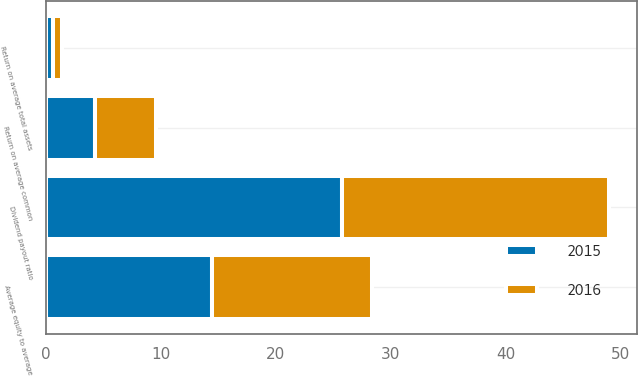Convert chart to OTSL. <chart><loc_0><loc_0><loc_500><loc_500><stacked_bar_chart><ecel><fcel>Return on average total assets<fcel>Return on average common<fcel>Dividend payout ratio<fcel>Average equity to average<nl><fcel>2016<fcel>0.73<fcel>5.23<fcel>23.3<fcel>13.93<nl><fcel>2015<fcel>0.62<fcel>4.3<fcel>25.73<fcel>14.46<nl></chart> 